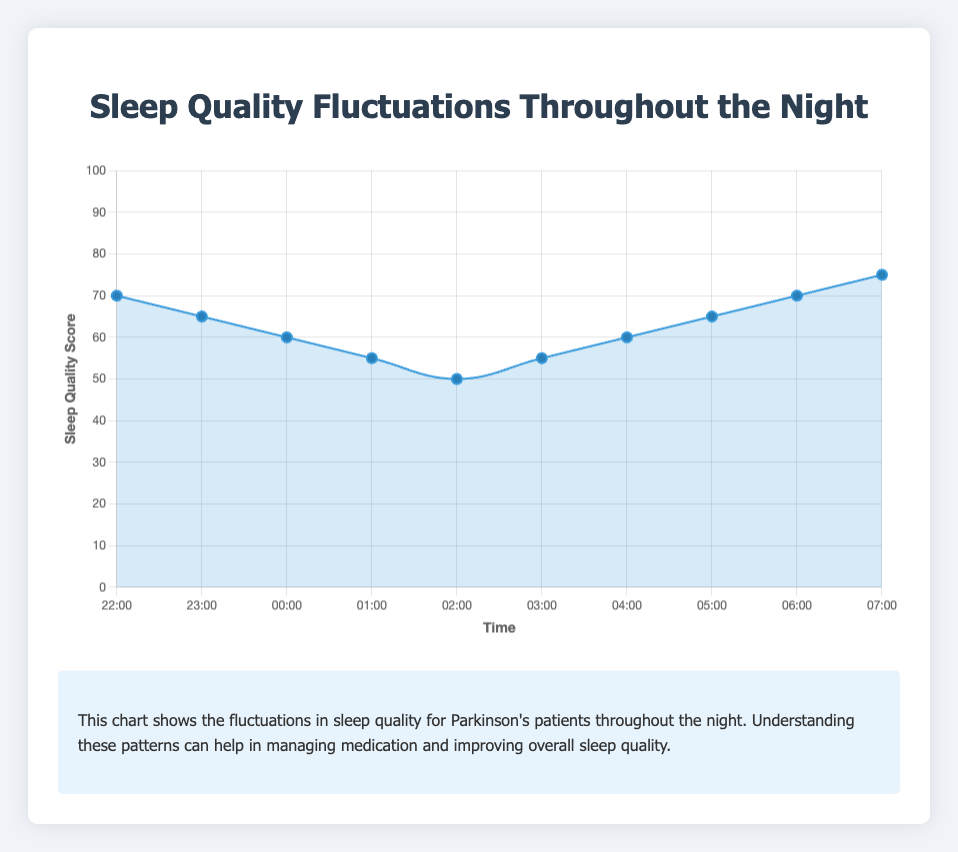Which time period shows the lowest sleep quality? The lowest sleep quality score on the chart is at 02:00, where the sleep quality is 50.
Answer: 02:00 At what time does sleep quality begin to rise after reaching the lowest point? The chart shows sleep quality begins to rise after 02:00, where it was at its lowest (50), and increases to 55 by 03:00.
Answer: 03:00 How does the sleep quality at 22:00 compare to that at 02:00? The sleep quality at 22:00 is 70, while at 02:00 it is 50. The quality at 22:00 is 20 points higher than at 02:00.
Answer: 22:00 is 20 points higher What is the average sleep quality from 00:00 to 04:00? The sleep quality values from 00:00 to 04:00 are 60, 55, 50, 55, and 60. Summing them gives 280 and there are 5 values, so the average is 280/5 = 56.
Answer: 56 What metric is associated with the sleep quality measurement at 05:00? The tooltip for the data point at 05:00 indicates that the associated metric is Sleep Fragmentation Index.
Answer: Sleep Fragmentation Index At what time is the second-highest sleep quality recorded and what is its score? The sleep quality scores show the second-highest value at 06:00 with a score of 70, just below the highest at 07:00, which is 75.
Answer: 06:00 with a score of 70 Describe the overall trend in sleep quality from 22:00 to 07:00. The sleep quality starts at 70 at 22:00, decreases to a low of 50 by 02:00, then gradually increases again, reaching its highest point at 75 by 07:00.
Answer: Starts high, decreases, then increases What is the range of sleep quality scores throughout the night? The maximum sleep quality score is 75 at 07:00 and the minimum is 50 at 02:00, so the range is 75 - 50 = 25.
Answer: 25 Between which two consecutive hours is the largest drop in sleep quality observed? The largest drop is observed between 22:00 and 23:00 where the sleep quality value drops from 70 to 65, a decrease of 5 points.
Answer: Between 22:00 and 23:00 